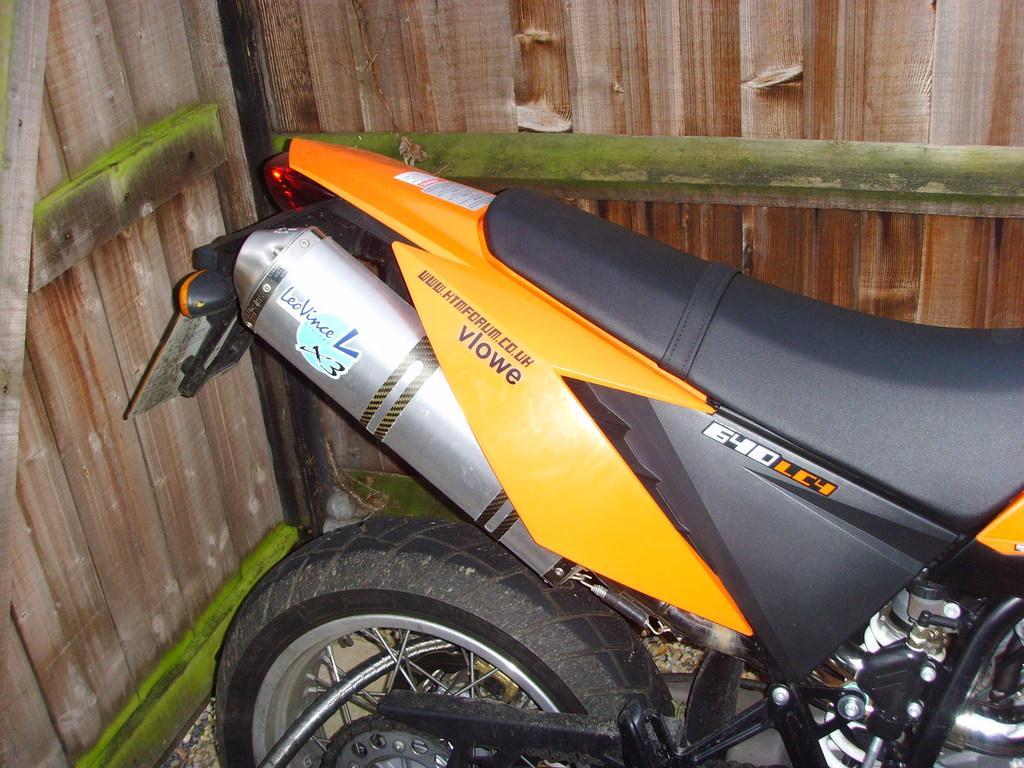Can you describe this image briefly? In this picture we can see a motorbike parked on the path and behind the bike they are looks like wooden walls. 